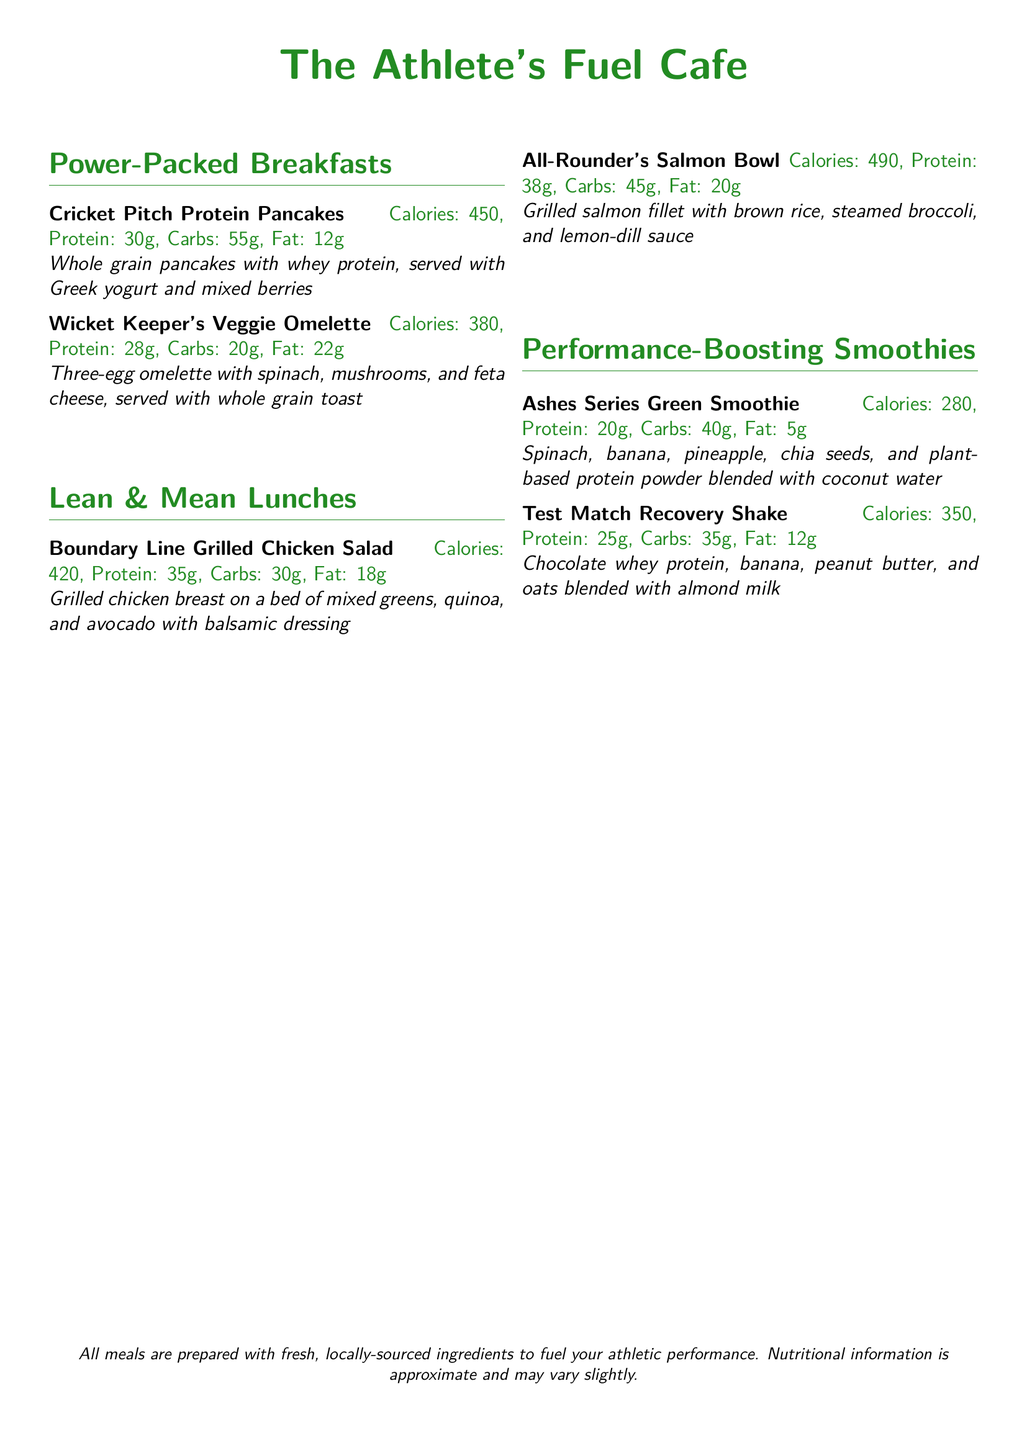What is the name of the cafe? The name of the cafe is prominently featured at the top of the document.
Answer: The Athlete's Fuel Cafe How many grams of protein are in the Cricket Pitch Protein Pancakes? The document lists the nutritional information for each food item, including the protein amount.
Answer: 30g What type of protein is used in the Test Match Recovery Shake? The document specifies the main ingredients of the shake, including the source of protein.
Answer: Chocolate whey protein How many calories does the Boundary Line Grilled Chicken Salad contain? The caloric content is detailed in the nutritional information for each menu item.
Answer: 420 Which menu item has avocado as an ingredient? The document provides ingredient details for each menu item, allowing identification of dishes containing avocado.
Answer: Boundary Line Grilled Chicken Salad What is the main carbohydrate source in the All-Rounder's Salmon Bowl? The document mentions the primary components of the dish, which include the carbohydrate source.
Answer: Brown rice Which smoothie contains banana? The document lists the ingredients for each smoothie, indicating which ones include banana.
Answer: Both Ashes Series Green Smoothie and Test Match Recovery Shake Which meal has the highest calories? By comparing the calorie counts of each menu item, it can be determined which has the highest.
Answer: All-Rounder's Salmon Bowl (490) 